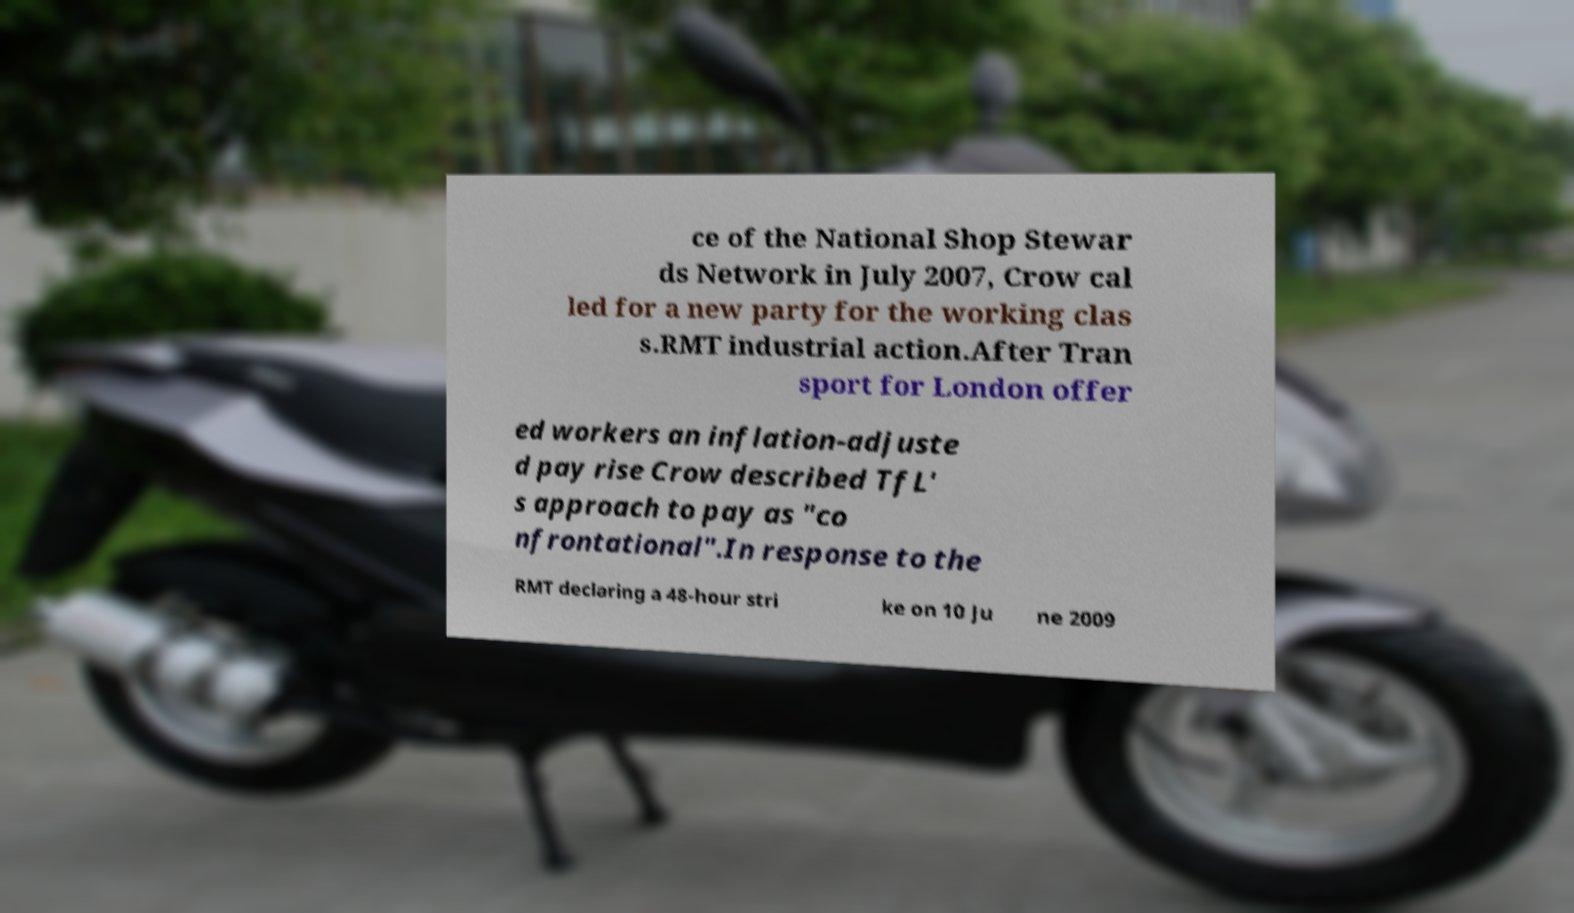I need the written content from this picture converted into text. Can you do that? ce of the National Shop Stewar ds Network in July 2007, Crow cal led for a new party for the working clas s.RMT industrial action.After Tran sport for London offer ed workers an inflation-adjuste d pay rise Crow described TfL' s approach to pay as "co nfrontational".In response to the RMT declaring a 48-hour stri ke on 10 Ju ne 2009 